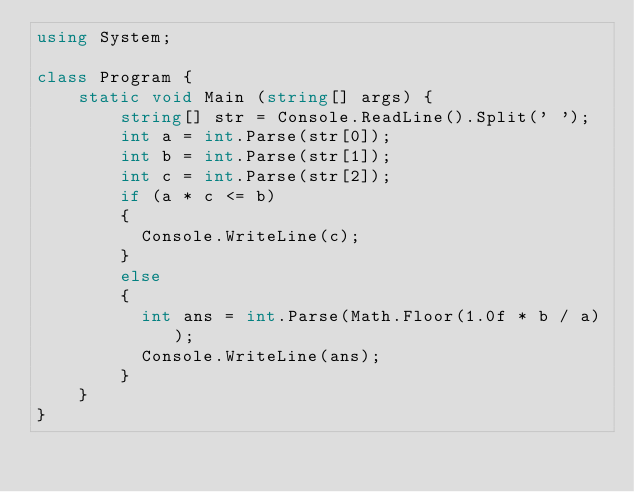Convert code to text. <code><loc_0><loc_0><loc_500><loc_500><_C#_>using System;
 
class Program {
	static void Main (string[] args) {
		string[] str = Console.ReadLine().Split(' ');
      	int a = int.Parse(str[0]);
      	int b = int.Parse(str[1]);
      	int c = int.Parse(str[2]);
      	if (a * c <= b) 
        {
          Console.WriteLine(c);
        }
      	else 
        {
          int ans = int.Parse(Math.Floor(1.0f * b / a));
          Console.WriteLine(ans);
        }
	}
}</code> 